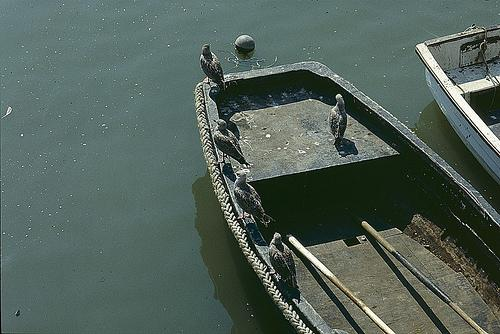What are the two long poles? oars 